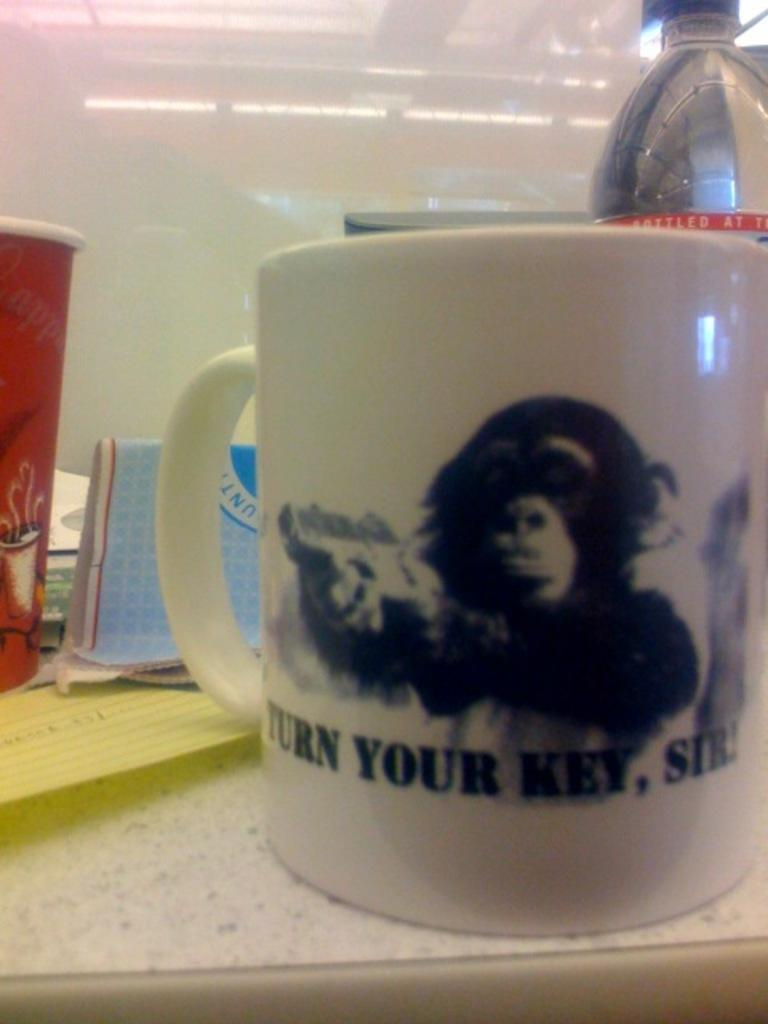<image>
Describe the image concisely. A close up of a mug that reads turn your key, sir! 